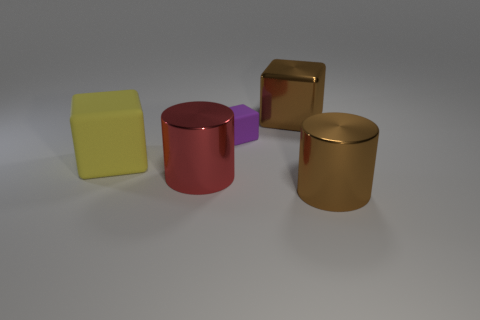There is a tiny purple matte cube; how many large shiny blocks are right of it?
Keep it short and to the point. 1. The large thing right of the big thing behind the large yellow block is made of what material?
Your answer should be compact. Metal. Are there any tiny rubber things of the same color as the big rubber thing?
Your response must be concise. No. There is a purple cube that is made of the same material as the large yellow block; what is its size?
Ensure brevity in your answer.  Small. Are there any other things that have the same color as the tiny block?
Provide a short and direct response. No. There is a rubber thing that is to the left of the red cylinder; what is its color?
Your response must be concise. Yellow. There is a big brown thing in front of the metallic cube that is right of the yellow cube; are there any big red objects that are in front of it?
Offer a very short reply. No. Are there more rubber cubes to the right of the brown metal cube than big cyan cubes?
Keep it short and to the point. No. Do the rubber thing that is on the left side of the large red metal thing and the small object have the same shape?
Your answer should be compact. Yes. Is there any other thing that has the same material as the purple thing?
Make the answer very short. Yes. 